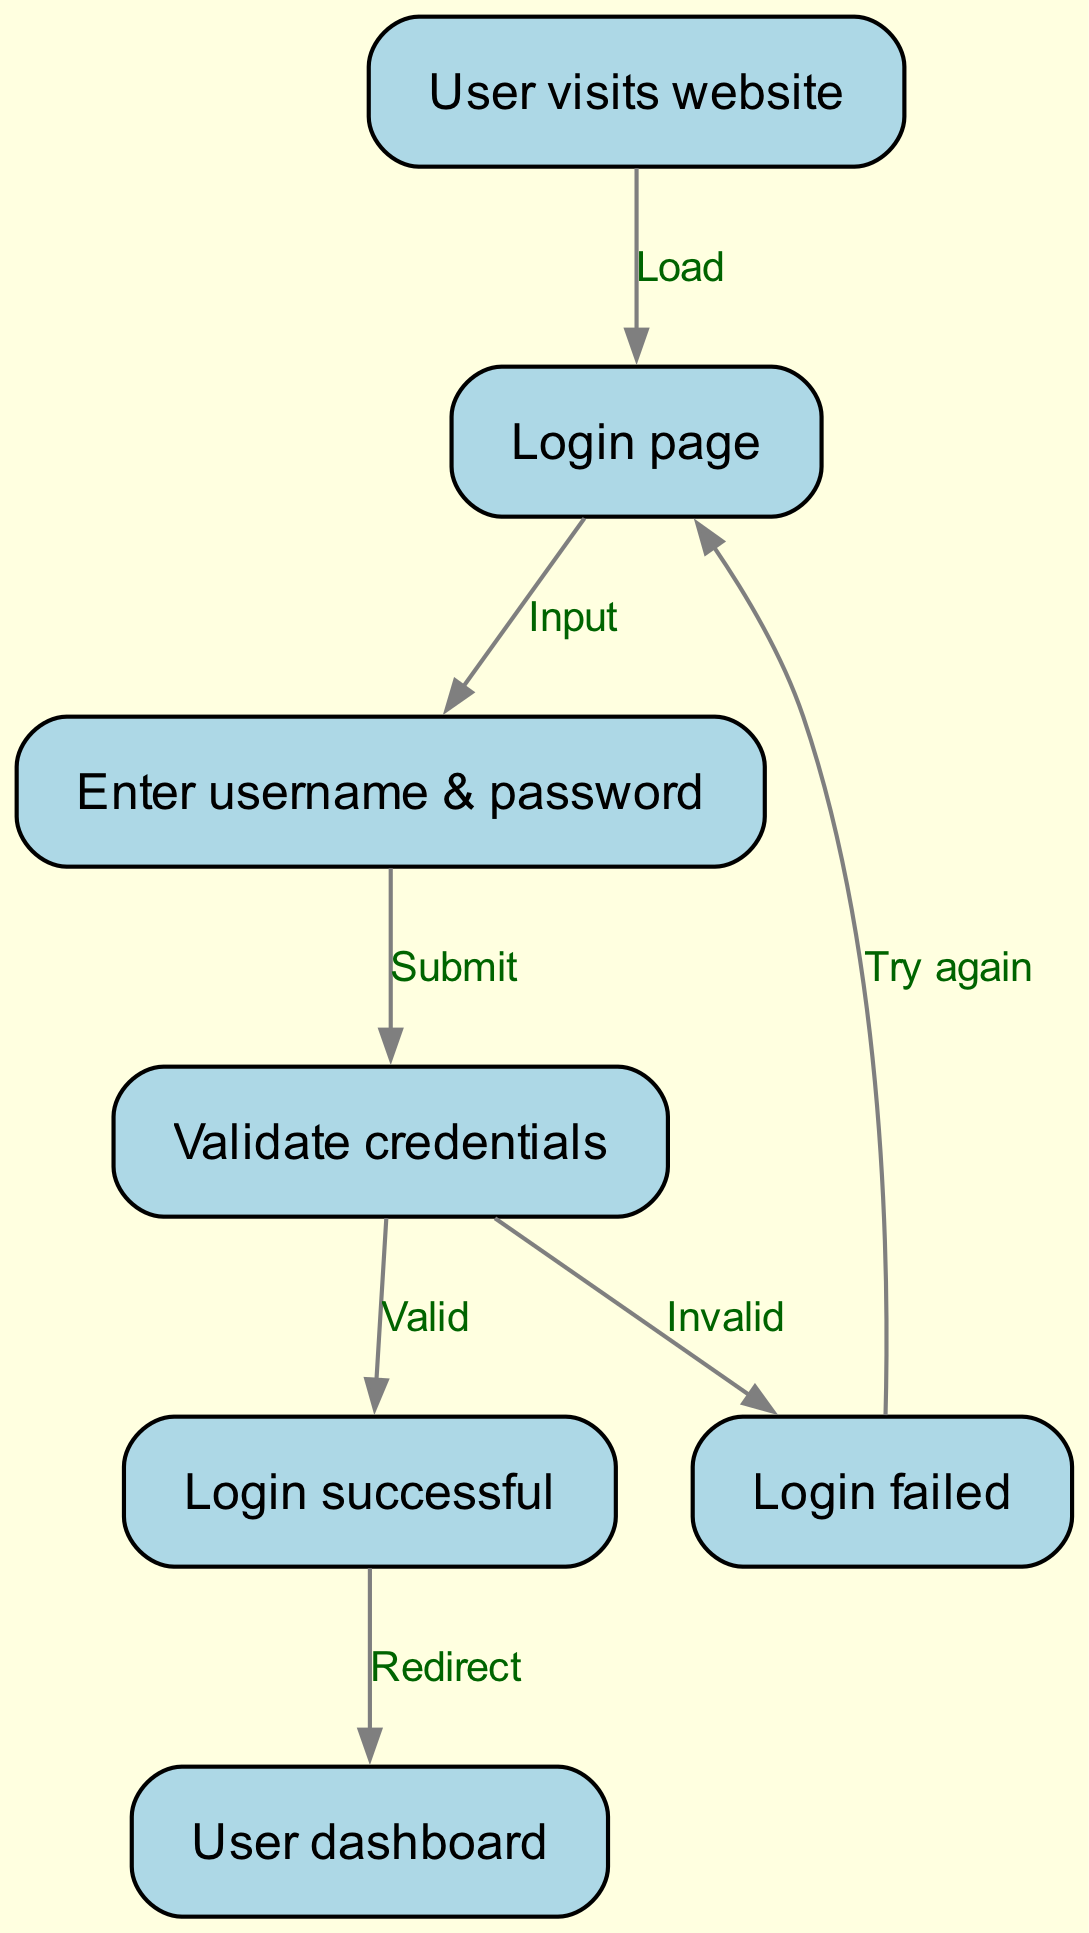What is the first action in the flowchart? The flowchart begins with the user visiting the website, indicating that this is the initial action taken in the process.
Answer: User visits website How many nodes are there in the diagram? The diagram has a total of seven nodes: start, login page, credentials, validate, success, failure, and dashboard. By counting these distinct elements, we identify them all.
Answer: 7 What happens after entering the credentials? After entering the credentials, the next step is submitting those credentials, which leads to the validation process. This is represented by an arrow connecting the credentials to the validate node.
Answer: Validate credentials What is the outcome if the credentials are valid? If the credentials are valid, the flowchart states that the next step is a successful login, which indicates that the user is allowed access to the site.
Answer: Login successful Where does the flow go if the login fails? If the login fails, the flowchart indicates a return to the login page, allowing the user to try again. This is shown by the connection from the failure node back to the login page.
Answer: Try again What is the final node in the flowchart? The final node in the flowchart, shown as the endpoint after a successful login, directs the user to their dashboard, concluding this user authentication process.
Answer: User dashboard How many edges are present in the diagram? There are a total of six edges in the diagram that represent the transitions between the nodes, indicating the flow of actions and decisions. By examining the connections, we find this total.
Answer: 6 What does the 'Input' label represent in the diagram? The 'Input' label represents the action of the user entering their username and password on the login page, facilitating the transition to the next step in the flowchart.
Answer: Enter username & password What must happen before reaching the user dashboard? Before reaching the user dashboard, it is required for the user to successfully log in, as indicated by the success node that leads to the dashboard. This success condition must be met first.
Answer: Login successful 